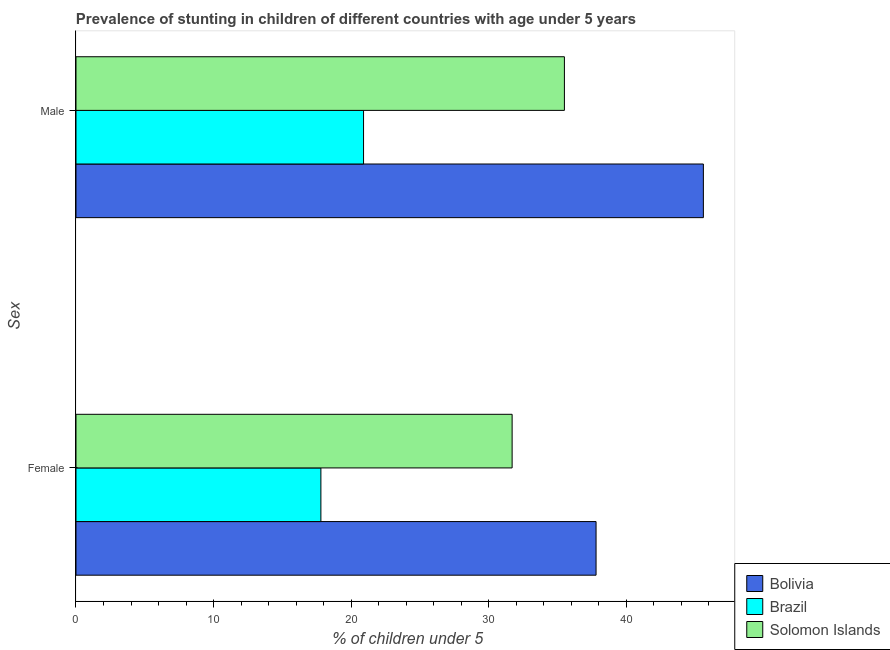How many groups of bars are there?
Your response must be concise. 2. Are the number of bars on each tick of the Y-axis equal?
Your answer should be very brief. Yes. How many bars are there on the 1st tick from the top?
Make the answer very short. 3. What is the percentage of stunted male children in Bolivia?
Offer a very short reply. 45.6. Across all countries, what is the maximum percentage of stunted female children?
Provide a succinct answer. 37.8. Across all countries, what is the minimum percentage of stunted male children?
Provide a succinct answer. 20.9. In which country was the percentage of stunted female children minimum?
Your answer should be very brief. Brazil. What is the total percentage of stunted female children in the graph?
Make the answer very short. 87.3. What is the difference between the percentage of stunted male children in Bolivia and that in Brazil?
Your response must be concise. 24.7. What is the difference between the percentage of stunted male children in Brazil and the percentage of stunted female children in Bolivia?
Ensure brevity in your answer.  -16.9. What is the average percentage of stunted male children per country?
Give a very brief answer. 34. What is the difference between the percentage of stunted male children and percentage of stunted female children in Bolivia?
Provide a succinct answer. 7.8. In how many countries, is the percentage of stunted female children greater than 26 %?
Offer a very short reply. 2. What is the ratio of the percentage of stunted male children in Brazil to that in Bolivia?
Make the answer very short. 0.46. Is the percentage of stunted female children in Bolivia less than that in Brazil?
Give a very brief answer. No. In how many countries, is the percentage of stunted male children greater than the average percentage of stunted male children taken over all countries?
Make the answer very short. 2. What does the 2nd bar from the top in Female represents?
Offer a very short reply. Brazil. Are all the bars in the graph horizontal?
Your answer should be very brief. Yes. How many countries are there in the graph?
Your answer should be compact. 3. What is the difference between two consecutive major ticks on the X-axis?
Make the answer very short. 10. Are the values on the major ticks of X-axis written in scientific E-notation?
Offer a very short reply. No. Does the graph contain any zero values?
Offer a very short reply. No. How many legend labels are there?
Your answer should be compact. 3. How are the legend labels stacked?
Give a very brief answer. Vertical. What is the title of the graph?
Your response must be concise. Prevalence of stunting in children of different countries with age under 5 years. Does "European Union" appear as one of the legend labels in the graph?
Keep it short and to the point. No. What is the label or title of the X-axis?
Your answer should be very brief.  % of children under 5. What is the label or title of the Y-axis?
Offer a very short reply. Sex. What is the  % of children under 5 in Bolivia in Female?
Offer a very short reply. 37.8. What is the  % of children under 5 in Brazil in Female?
Your answer should be very brief. 17.8. What is the  % of children under 5 of Solomon Islands in Female?
Your answer should be compact. 31.7. What is the  % of children under 5 in Bolivia in Male?
Provide a succinct answer. 45.6. What is the  % of children under 5 in Brazil in Male?
Offer a terse response. 20.9. What is the  % of children under 5 in Solomon Islands in Male?
Your answer should be compact. 35.5. Across all Sex, what is the maximum  % of children under 5 in Bolivia?
Ensure brevity in your answer.  45.6. Across all Sex, what is the maximum  % of children under 5 in Brazil?
Keep it short and to the point. 20.9. Across all Sex, what is the maximum  % of children under 5 of Solomon Islands?
Keep it short and to the point. 35.5. Across all Sex, what is the minimum  % of children under 5 in Bolivia?
Keep it short and to the point. 37.8. Across all Sex, what is the minimum  % of children under 5 in Brazil?
Ensure brevity in your answer.  17.8. Across all Sex, what is the minimum  % of children under 5 in Solomon Islands?
Your response must be concise. 31.7. What is the total  % of children under 5 of Bolivia in the graph?
Offer a very short reply. 83.4. What is the total  % of children under 5 of Brazil in the graph?
Give a very brief answer. 38.7. What is the total  % of children under 5 of Solomon Islands in the graph?
Make the answer very short. 67.2. What is the difference between the  % of children under 5 of Bolivia in Female and that in Male?
Keep it short and to the point. -7.8. What is the difference between the  % of children under 5 in Brazil in Female and that in Male?
Your answer should be very brief. -3.1. What is the difference between the  % of children under 5 in Bolivia in Female and the  % of children under 5 in Solomon Islands in Male?
Make the answer very short. 2.3. What is the difference between the  % of children under 5 of Brazil in Female and the  % of children under 5 of Solomon Islands in Male?
Your response must be concise. -17.7. What is the average  % of children under 5 of Bolivia per Sex?
Provide a short and direct response. 41.7. What is the average  % of children under 5 of Brazil per Sex?
Ensure brevity in your answer.  19.35. What is the average  % of children under 5 in Solomon Islands per Sex?
Give a very brief answer. 33.6. What is the difference between the  % of children under 5 of Bolivia and  % of children under 5 of Brazil in Female?
Keep it short and to the point. 20. What is the difference between the  % of children under 5 in Bolivia and  % of children under 5 in Solomon Islands in Female?
Your response must be concise. 6.1. What is the difference between the  % of children under 5 of Bolivia and  % of children under 5 of Brazil in Male?
Offer a very short reply. 24.7. What is the difference between the  % of children under 5 in Brazil and  % of children under 5 in Solomon Islands in Male?
Your answer should be compact. -14.6. What is the ratio of the  % of children under 5 of Bolivia in Female to that in Male?
Ensure brevity in your answer.  0.83. What is the ratio of the  % of children under 5 in Brazil in Female to that in Male?
Give a very brief answer. 0.85. What is the ratio of the  % of children under 5 in Solomon Islands in Female to that in Male?
Your answer should be very brief. 0.89. What is the difference between the highest and the second highest  % of children under 5 in Bolivia?
Your answer should be very brief. 7.8. What is the difference between the highest and the second highest  % of children under 5 of Brazil?
Your response must be concise. 3.1. What is the difference between the highest and the second highest  % of children under 5 of Solomon Islands?
Keep it short and to the point. 3.8. What is the difference between the highest and the lowest  % of children under 5 of Brazil?
Provide a short and direct response. 3.1. 